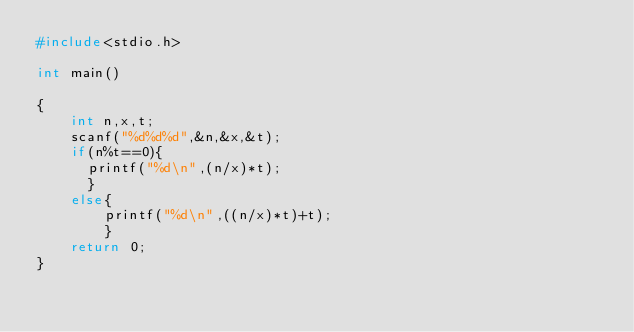Convert code to text. <code><loc_0><loc_0><loc_500><loc_500><_C_>#include<stdio.h>

int main()

{
    int n,x,t;
    scanf("%d%d%d",&n,&x,&t);
    if(n%t==0){
    	printf("%d\n",(n/x)*t);
    	}
  	else{
      	printf("%d\n",((n/x)*t)+t);
      	}
  	return 0;
}
</code> 